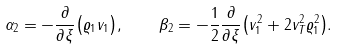<formula> <loc_0><loc_0><loc_500><loc_500>\alpha _ { 2 } = - { \frac { \partial } { \partial \xi } } { \left ( \varrho _ { 1 } v _ { 1 } \right ) } , \quad \beta _ { 2 } = - { \frac { 1 } { 2 } } { \frac { \partial } { \partial \xi } } { \left ( v _ { 1 } ^ { 2 } + 2 v _ { T } ^ { 2 } \varrho _ { 1 } ^ { 2 } \right ) } .</formula> 